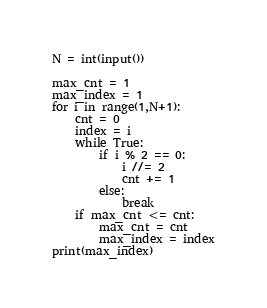<code> <loc_0><loc_0><loc_500><loc_500><_Python_>N = int(input())

max_cnt = 1
max_index = 1
for i in range(1,N+1):
    cnt = 0
    index = i
    while True:
        if i % 2 == 0:
            i //= 2
            cnt += 1
        else:
            break
    if max_cnt <= cnt:
        max_cnt = cnt
        max_index = index
print(max_index)</code> 